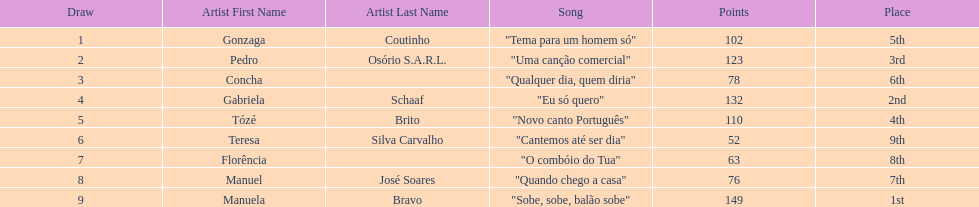Which artist came in last place? Teresa Silva Carvalho. 